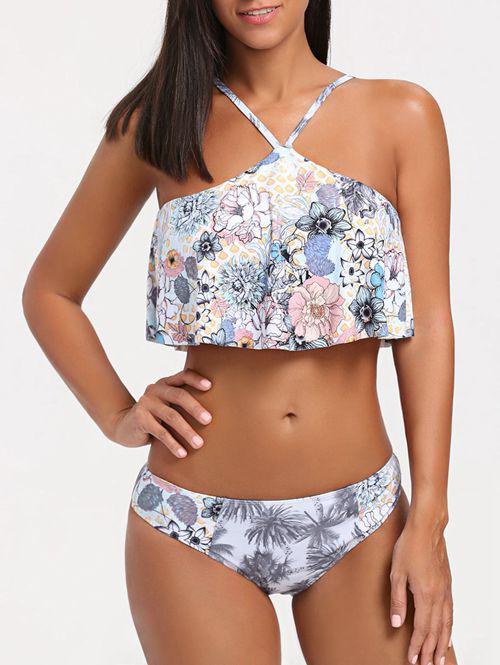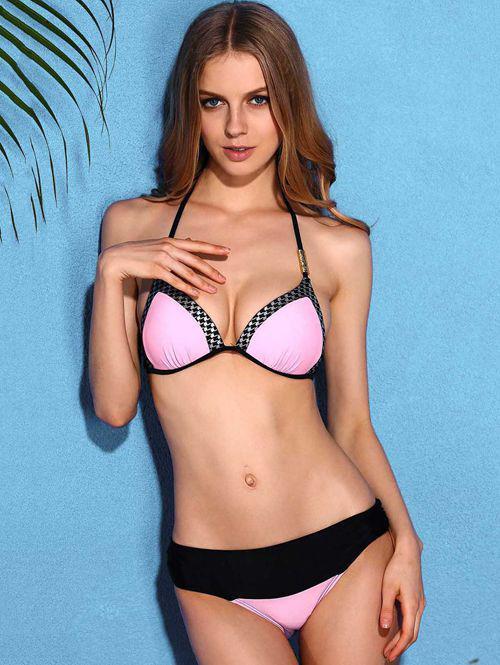The first image is the image on the left, the second image is the image on the right. For the images displayed, is the sentence "Both images contain the same number of women." factually correct? Answer yes or no. Yes. The first image is the image on the left, the second image is the image on the right. Given the left and right images, does the statement "The right image shows exactly two models wearing bikinis with tops that extend over the chest and taper up to the neck." hold true? Answer yes or no. No. 